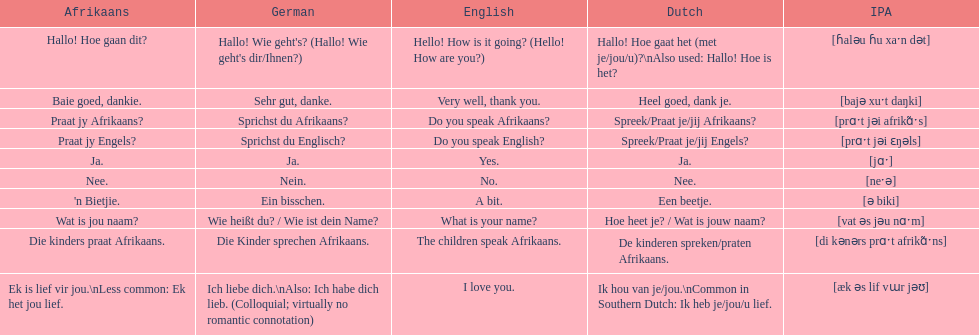How would you say the phrase the children speak afrikaans in afrikaans? Die kinders praat Afrikaans. I'm looking to parse the entire table for insights. Could you assist me with that? {'header': ['Afrikaans', 'German', 'English', 'Dutch', 'IPA'], 'rows': [['Hallo! Hoe gaan dit?', "Hallo! Wie geht's? (Hallo! Wie geht's dir/Ihnen?)", 'Hello! How is it going? (Hello! How are you?)', 'Hallo! Hoe gaat het (met je/jou/u)?\\nAlso used: Hallo! Hoe is het?', '[ɦaləu ɦu xaˑn dət]'], ['Baie goed, dankie.', 'Sehr gut, danke.', 'Very well, thank you.', 'Heel goed, dank je.', '[bajə xuˑt daŋki]'], ['Praat jy Afrikaans?', 'Sprichst du Afrikaans?', 'Do you speak Afrikaans?', 'Spreek/Praat je/jij Afrikaans?', '[prɑˑt jəi afrikɑ̃ˑs]'], ['Praat jy Engels?', 'Sprichst du Englisch?', 'Do you speak English?', 'Spreek/Praat je/jij Engels?', '[prɑˑt jəi ɛŋəls]'], ['Ja.', 'Ja.', 'Yes.', 'Ja.', '[jɑˑ]'], ['Nee.', 'Nein.', 'No.', 'Nee.', '[neˑə]'], ["'n Bietjie.", 'Ein bisschen.', 'A bit.', 'Een beetje.', '[ə biki]'], ['Wat is jou naam?', 'Wie heißt du? / Wie ist dein Name?', 'What is your name?', 'Hoe heet je? / Wat is jouw naam?', '[vat əs jəu nɑˑm]'], ['Die kinders praat Afrikaans.', 'Die Kinder sprechen Afrikaans.', 'The children speak Afrikaans.', 'De kinderen spreken/praten Afrikaans.', '[di kənərs prɑˑt afrikɑ̃ˑns]'], ['Ek is lief vir jou.\\nLess common: Ek het jou lief.', 'Ich liebe dich.\\nAlso: Ich habe dich lieb. (Colloquial; virtually no romantic connotation)', 'I love you.', 'Ik hou van je/jou.\\nCommon in Southern Dutch: Ik heb je/jou/u lief.', '[æk əs lif vɯr jəʊ]']]} How would you say the previous phrase in german? Die Kinder sprechen Afrikaans. 